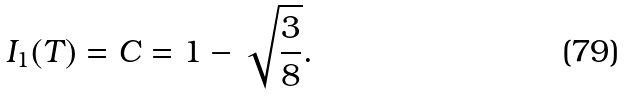Convert formula to latex. <formula><loc_0><loc_0><loc_500><loc_500>I _ { 1 } ( T ) = C = 1 - \sqrt { \frac { 3 } { 8 } } .</formula> 